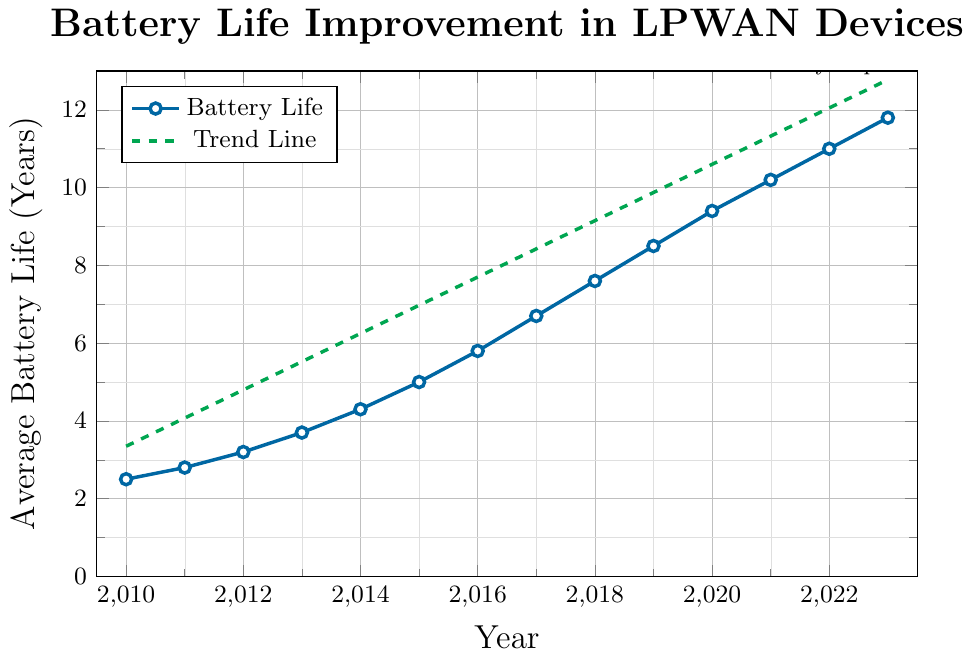What is the average battery life in 2015? Locate the data point for the year 2015 on the x-axis, then look up to find the corresponding y-value. It is 5.0 years
Answer: 5.0 years In which year did the average battery life first exceed 4 years? Identify the y-values and find the first instance where they surpass 4 years. The battery life exceeds 4 years in 2014
Answer: 2014 How much did the average battery life increase from 2012 to 2016? Subtract the battery life in 2012 from the battery life in 2016: 5.8 - 3.2 = 2.6 years
Answer: 2.6 years What is the approximate rate of battery life improvement per year according to the trend line? Look at the trend line equation provided. The slope (rise over run) indicates the rate of improvement. The equation is y = 0.7252*x - 1454.304, so the rate of improvement is approximately 0.7252 years per year
Answer: 0.7252 years per year Which year saw the most significant year-over-year improvement in average battery life? Inspect the data table or plotted points to compare year-over-year differences. The biggest improvement occurred from 2014 to 2015 (5.0 - 4.3 = 0.7 years)
Answer: 2014-2015 What is the color of the line representing the trend line? The trend line is dashed and plotted in green color. Look at the plotted lines and observe the color used for the dashed line
Answer: Green By how many years did the average battery life improve from 2010 to 2023? Subtract the battery life in 2010 from the battery life in 2023: 11.8 - 2.5 = 9.3 years
Answer: 9.3 years Is the battery life increasing at a constant rate or changing rate according to the trend line? The trend line is linear, indicating a constant rate of increase. The slope of the trend line is consistent
Answer: Constant rate What average battery life is predicted for 2025 if the current trend continues? Use the trend line equation y = 0.7252*x - 1454.304. Substitute x with 2025: y = 0.7252*2025 - 1454.304, which is approximately 13.177 years
Answer: 13.2 years Compare the average battery life between the first and last data points in the figure. The first data point (2010) has a battery life of 2.5 years, and the last data point (2023) has a battery life of 11.8 years. The difference is 11.8 - 2.5 = 9.3 years
Answer: 9.3 years 